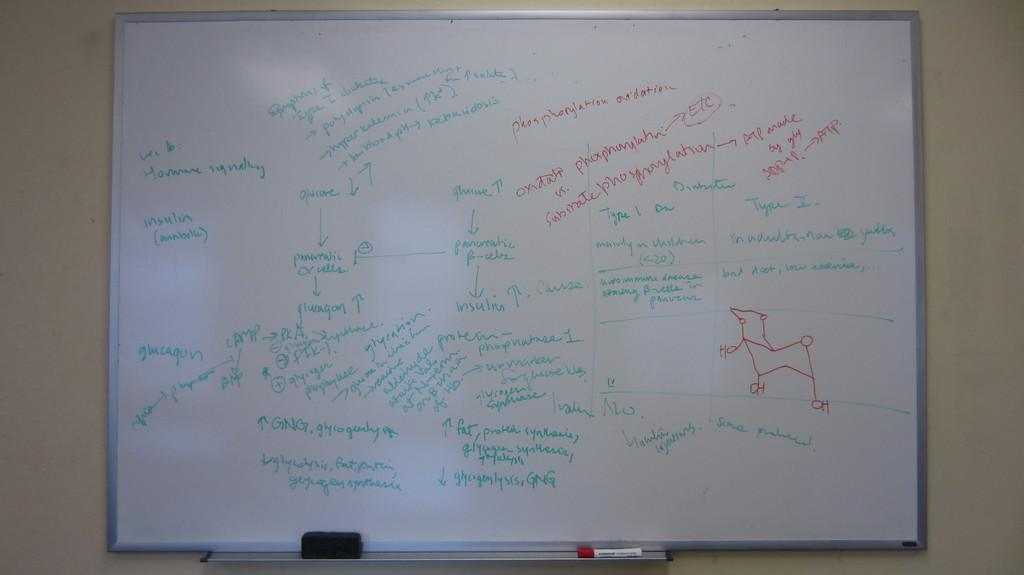<image>
Describe the image concisely. A white board with a lot of words on it, one of which is insulin. 